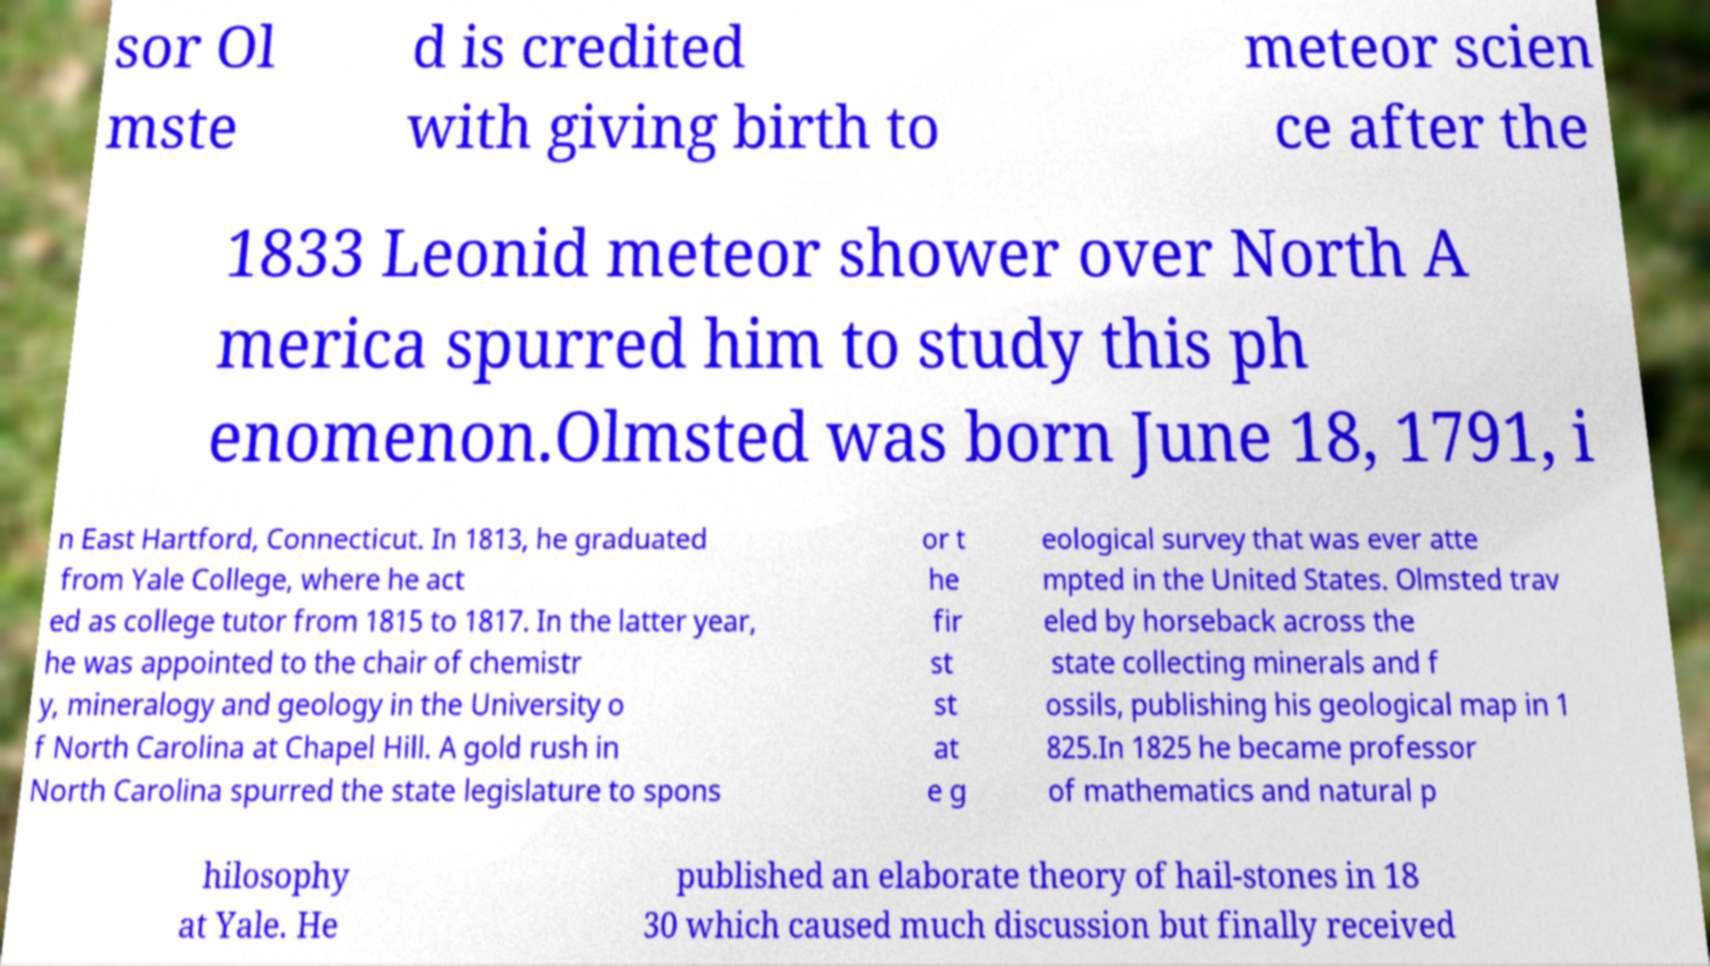I need the written content from this picture converted into text. Can you do that? sor Ol mste d is credited with giving birth to meteor scien ce after the 1833 Leonid meteor shower over North A merica spurred him to study this ph enomenon.Olmsted was born June 18, 1791, i n East Hartford, Connecticut. In 1813, he graduated from Yale College, where he act ed as college tutor from 1815 to 1817. In the latter year, he was appointed to the chair of chemistr y, mineralogy and geology in the University o f North Carolina at Chapel Hill. A gold rush in North Carolina spurred the state legislature to spons or t he fir st st at e g eological survey that was ever atte mpted in the United States. Olmsted trav eled by horseback across the state collecting minerals and f ossils, publishing his geological map in 1 825.In 1825 he became professor of mathematics and natural p hilosophy at Yale. He published an elaborate theory of hail-stones in 18 30 which caused much discussion but finally received 